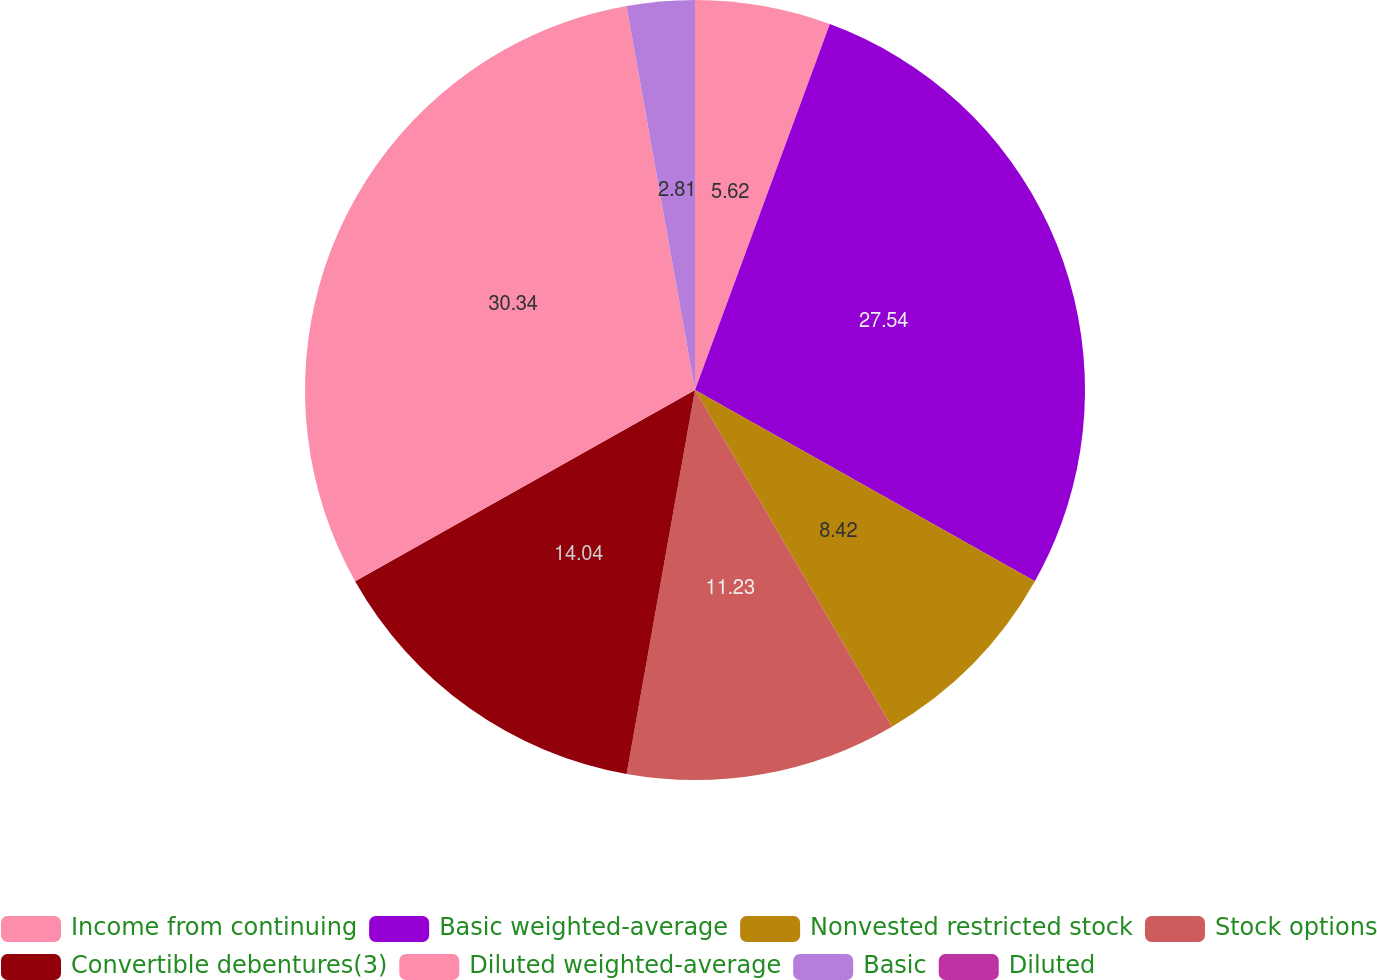Convert chart to OTSL. <chart><loc_0><loc_0><loc_500><loc_500><pie_chart><fcel>Income from continuing<fcel>Basic weighted-average<fcel>Nonvested restricted stock<fcel>Stock options<fcel>Convertible debentures(3)<fcel>Diluted weighted-average<fcel>Basic<fcel>Diluted<nl><fcel>5.62%<fcel>27.54%<fcel>8.42%<fcel>11.23%<fcel>14.04%<fcel>30.35%<fcel>2.81%<fcel>0.0%<nl></chart> 